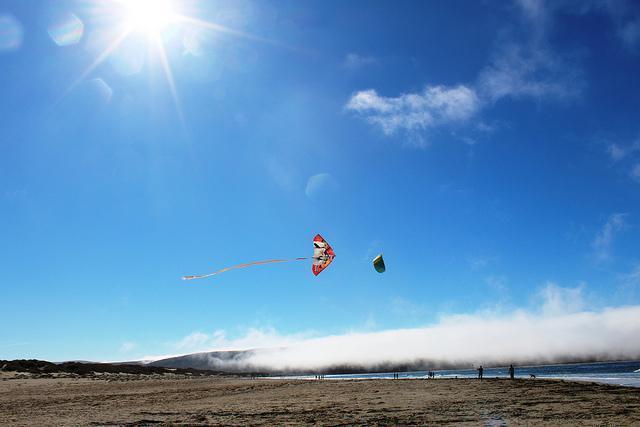How many people appear in the picture?
Give a very brief answer. 2. How many kites are in the sky?
Give a very brief answer. 2. How many airplane engines can you see?
Give a very brief answer. 0. 